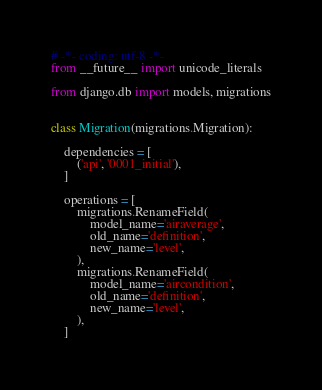<code> <loc_0><loc_0><loc_500><loc_500><_Python_># -*- coding: utf-8 -*-
from __future__ import unicode_literals

from django.db import models, migrations


class Migration(migrations.Migration):

    dependencies = [
        ('api', '0001_initial'),
    ]

    operations = [
        migrations.RenameField(
            model_name='airaverage',
            old_name='definition',
            new_name='level',
        ),
        migrations.RenameField(
            model_name='aircondition',
            old_name='definition',
            new_name='level',
        ),
    ]
</code> 